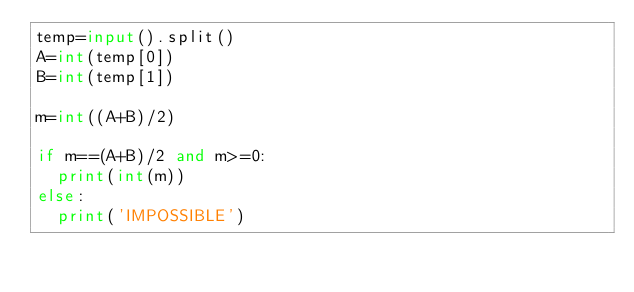<code> <loc_0><loc_0><loc_500><loc_500><_Python_>temp=input().split()
A=int(temp[0])
B=int(temp[1])

m=int((A+B)/2)

if m==(A+B)/2 and m>=0:
  print(int(m))
else:
  print('IMPOSSIBLE')</code> 